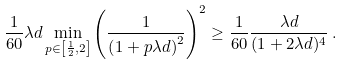<formula> <loc_0><loc_0><loc_500><loc_500>\frac { 1 } { 6 0 } \lambda d \min _ { p \in \left [ \frac { 1 } { 2 } , 2 \right ] } \left ( \frac { 1 } { \left ( 1 + p \lambda d \right ) ^ { 2 } } \right ) ^ { 2 } \geq \frac { 1 } { 6 0 } \frac { \lambda d } { ( 1 + 2 \lambda d ) ^ { 4 } } \, .</formula> 